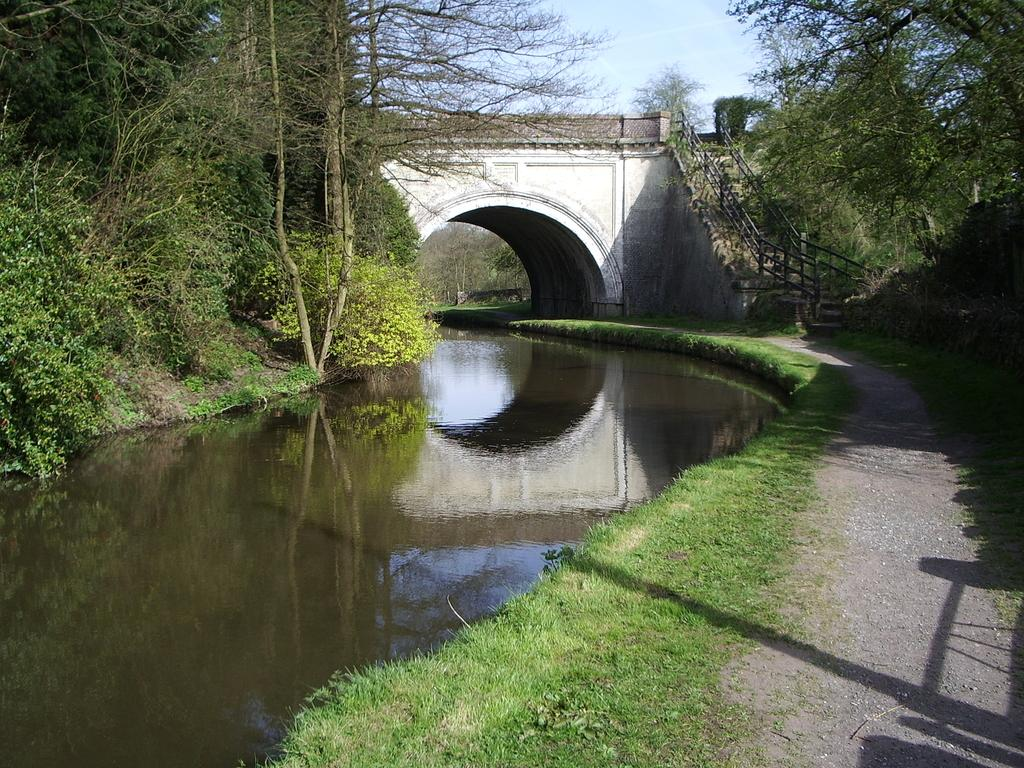What is the primary element visible in the image? There is water in the image. What type of vegetation is near the water? There are trees beside the water. Is there any structure that crosses over the water? Yes, there is a bridge over the water in the image. How many birds are sitting on the dad's shoulder in the image? There are no birds or dad present in the image; it features water, trees, and a bridge. 